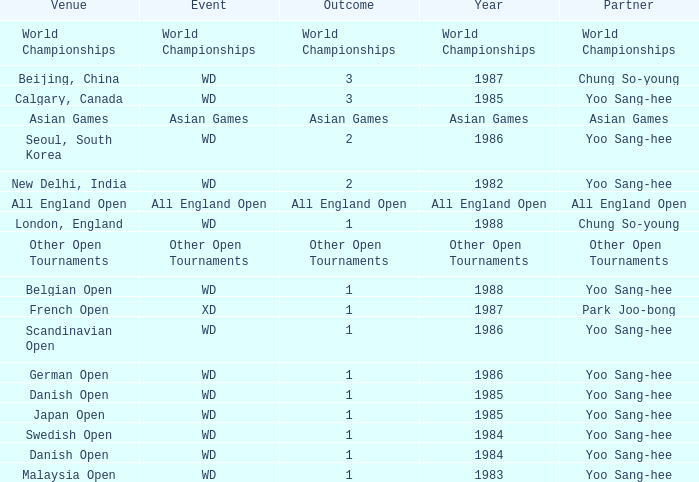In what Year did the German Open have Yoo Sang-Hee as Partner? 1986.0. 